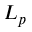<formula> <loc_0><loc_0><loc_500><loc_500>L _ { p }</formula> 